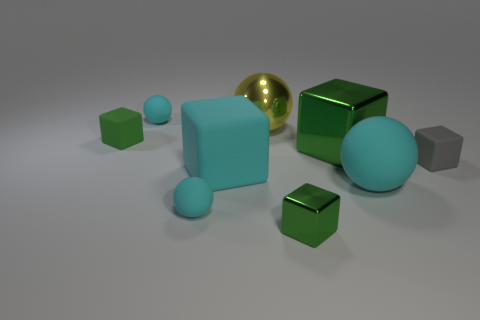There is a big object that is in front of the large green block and on the right side of the large yellow object; what is its color?
Provide a short and direct response. Cyan. There is a large cube to the right of the tiny shiny thing; what material is it?
Offer a very short reply. Metal. What is the size of the gray matte object?
Provide a succinct answer. Small. How many yellow things are either metal things or large objects?
Your answer should be very brief. 1. How big is the green object left of the big metallic ball right of the green matte object?
Keep it short and to the point. Small. Is the color of the big shiny cube the same as the tiny rubber cube on the left side of the small green metal block?
Provide a succinct answer. Yes. How many other objects are there of the same material as the big yellow object?
Your response must be concise. 2. What shape is the large object that is made of the same material as the large cyan block?
Provide a short and direct response. Sphere. Is there anything else that is the same color as the shiny ball?
Offer a terse response. No. What size is the rubber object that is the same color as the small metallic cube?
Ensure brevity in your answer.  Small. 